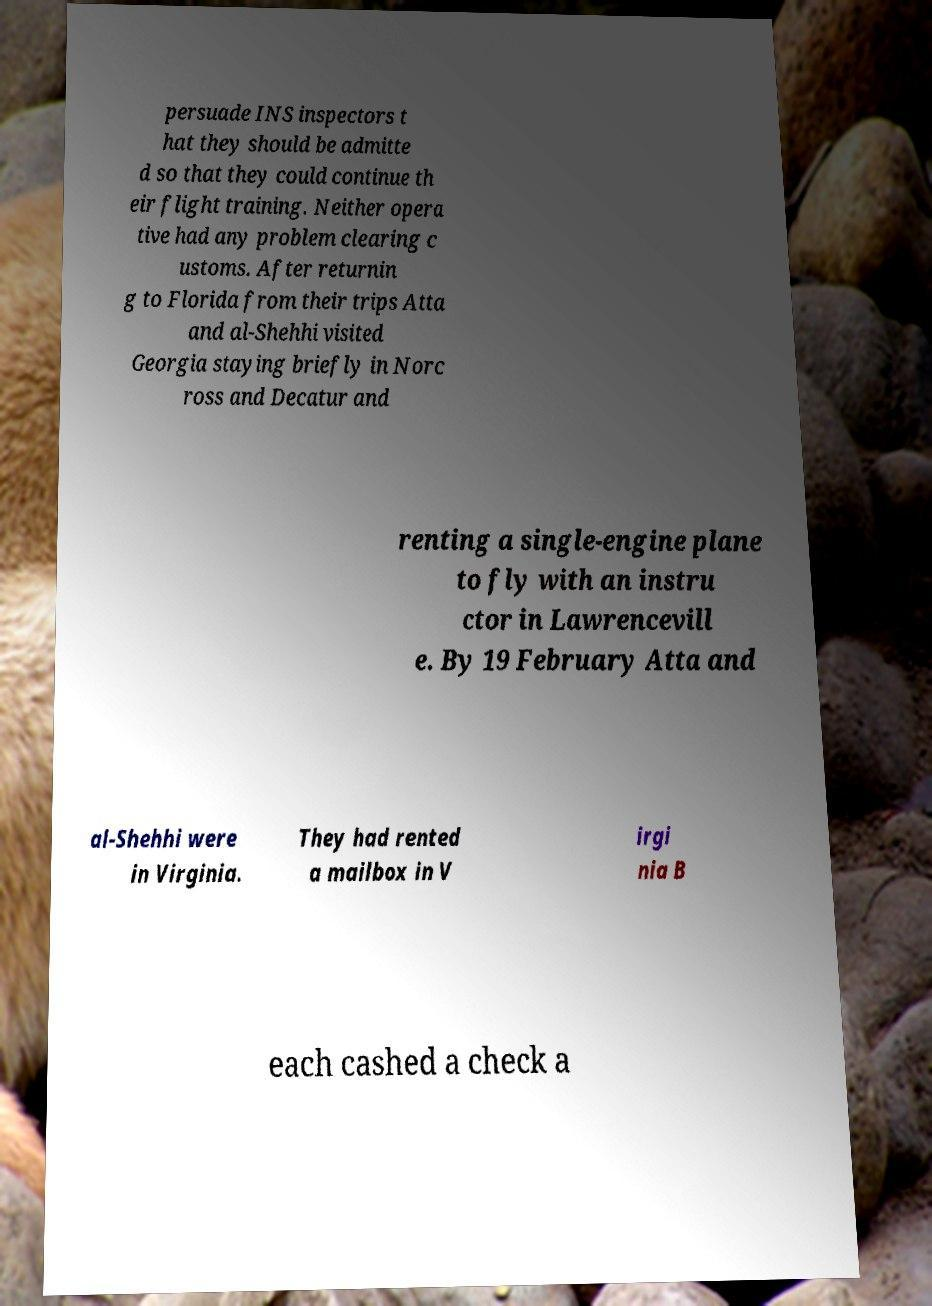Please read and relay the text visible in this image. What does it say? persuade INS inspectors t hat they should be admitte d so that they could continue th eir flight training. Neither opera tive had any problem clearing c ustoms. After returnin g to Florida from their trips Atta and al-Shehhi visited Georgia staying briefly in Norc ross and Decatur and renting a single-engine plane to fly with an instru ctor in Lawrencevill e. By 19 February Atta and al-Shehhi were in Virginia. They had rented a mailbox in V irgi nia B each cashed a check a 